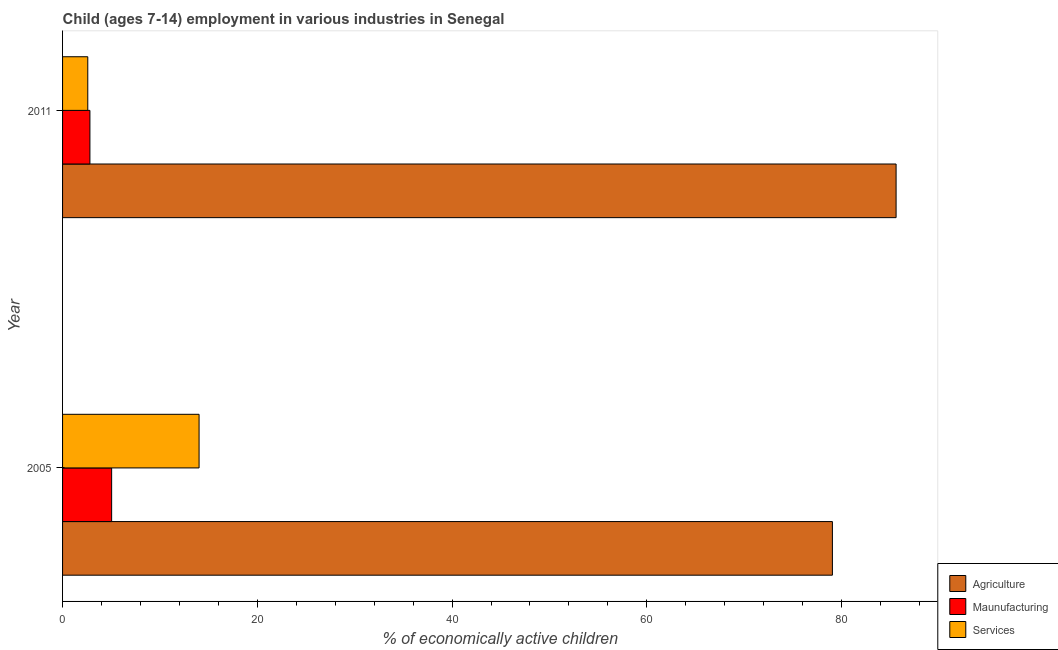Are the number of bars per tick equal to the number of legend labels?
Keep it short and to the point. Yes. How many bars are there on the 2nd tick from the top?
Offer a very short reply. 3. How many bars are there on the 2nd tick from the bottom?
Provide a succinct answer. 3. What is the label of the 2nd group of bars from the top?
Keep it short and to the point. 2005. What is the percentage of economically active children in services in 2011?
Provide a short and direct response. 2.59. Across all years, what is the maximum percentage of economically active children in services?
Provide a succinct answer. 14.02. Across all years, what is the minimum percentage of economically active children in manufacturing?
Make the answer very short. 2.81. In which year was the percentage of economically active children in agriculture maximum?
Your response must be concise. 2011. What is the total percentage of economically active children in agriculture in the graph?
Give a very brief answer. 164.66. What is the difference between the percentage of economically active children in agriculture in 2005 and that in 2011?
Your response must be concise. -6.54. What is the difference between the percentage of economically active children in services in 2005 and the percentage of economically active children in manufacturing in 2011?
Keep it short and to the point. 11.21. What is the average percentage of economically active children in agriculture per year?
Keep it short and to the point. 82.33. In the year 2011, what is the difference between the percentage of economically active children in manufacturing and percentage of economically active children in services?
Provide a succinct answer. 0.22. In how many years, is the percentage of economically active children in services greater than 28 %?
Provide a succinct answer. 0. What is the ratio of the percentage of economically active children in services in 2005 to that in 2011?
Keep it short and to the point. 5.41. Is the percentage of economically active children in agriculture in 2005 less than that in 2011?
Provide a succinct answer. Yes. Is the difference between the percentage of economically active children in agriculture in 2005 and 2011 greater than the difference between the percentage of economically active children in services in 2005 and 2011?
Your answer should be very brief. No. In how many years, is the percentage of economically active children in services greater than the average percentage of economically active children in services taken over all years?
Provide a short and direct response. 1. What does the 1st bar from the top in 2005 represents?
Your answer should be compact. Services. What does the 1st bar from the bottom in 2011 represents?
Your answer should be compact. Agriculture. Is it the case that in every year, the sum of the percentage of economically active children in agriculture and percentage of economically active children in manufacturing is greater than the percentage of economically active children in services?
Make the answer very short. Yes. How many years are there in the graph?
Provide a short and direct response. 2. Are the values on the major ticks of X-axis written in scientific E-notation?
Provide a short and direct response. No. Where does the legend appear in the graph?
Your answer should be very brief. Bottom right. How are the legend labels stacked?
Keep it short and to the point. Vertical. What is the title of the graph?
Offer a terse response. Child (ages 7-14) employment in various industries in Senegal. Does "Spain" appear as one of the legend labels in the graph?
Ensure brevity in your answer.  No. What is the label or title of the X-axis?
Provide a short and direct response. % of economically active children. What is the label or title of the Y-axis?
Offer a very short reply. Year. What is the % of economically active children in Agriculture in 2005?
Keep it short and to the point. 79.06. What is the % of economically active children of Maunufacturing in 2005?
Provide a short and direct response. 5.04. What is the % of economically active children of Services in 2005?
Give a very brief answer. 14.02. What is the % of economically active children in Agriculture in 2011?
Make the answer very short. 85.6. What is the % of economically active children in Maunufacturing in 2011?
Offer a terse response. 2.81. What is the % of economically active children of Services in 2011?
Ensure brevity in your answer.  2.59. Across all years, what is the maximum % of economically active children of Agriculture?
Offer a very short reply. 85.6. Across all years, what is the maximum % of economically active children in Maunufacturing?
Provide a succinct answer. 5.04. Across all years, what is the maximum % of economically active children of Services?
Your answer should be compact. 14.02. Across all years, what is the minimum % of economically active children in Agriculture?
Provide a succinct answer. 79.06. Across all years, what is the minimum % of economically active children in Maunufacturing?
Your answer should be very brief. 2.81. Across all years, what is the minimum % of economically active children of Services?
Your response must be concise. 2.59. What is the total % of economically active children in Agriculture in the graph?
Make the answer very short. 164.66. What is the total % of economically active children of Maunufacturing in the graph?
Offer a very short reply. 7.85. What is the total % of economically active children in Services in the graph?
Your answer should be very brief. 16.61. What is the difference between the % of economically active children in Agriculture in 2005 and that in 2011?
Your response must be concise. -6.54. What is the difference between the % of economically active children in Maunufacturing in 2005 and that in 2011?
Ensure brevity in your answer.  2.23. What is the difference between the % of economically active children in Services in 2005 and that in 2011?
Your answer should be very brief. 11.43. What is the difference between the % of economically active children of Agriculture in 2005 and the % of economically active children of Maunufacturing in 2011?
Provide a succinct answer. 76.25. What is the difference between the % of economically active children in Agriculture in 2005 and the % of economically active children in Services in 2011?
Your answer should be compact. 76.47. What is the difference between the % of economically active children of Maunufacturing in 2005 and the % of economically active children of Services in 2011?
Provide a short and direct response. 2.45. What is the average % of economically active children of Agriculture per year?
Keep it short and to the point. 82.33. What is the average % of economically active children of Maunufacturing per year?
Give a very brief answer. 3.92. What is the average % of economically active children of Services per year?
Give a very brief answer. 8.3. In the year 2005, what is the difference between the % of economically active children of Agriculture and % of economically active children of Maunufacturing?
Offer a very short reply. 74.02. In the year 2005, what is the difference between the % of economically active children in Agriculture and % of economically active children in Services?
Give a very brief answer. 65.04. In the year 2005, what is the difference between the % of economically active children in Maunufacturing and % of economically active children in Services?
Provide a short and direct response. -8.98. In the year 2011, what is the difference between the % of economically active children in Agriculture and % of economically active children in Maunufacturing?
Ensure brevity in your answer.  82.79. In the year 2011, what is the difference between the % of economically active children of Agriculture and % of economically active children of Services?
Keep it short and to the point. 83.01. In the year 2011, what is the difference between the % of economically active children of Maunufacturing and % of economically active children of Services?
Ensure brevity in your answer.  0.22. What is the ratio of the % of economically active children of Agriculture in 2005 to that in 2011?
Make the answer very short. 0.92. What is the ratio of the % of economically active children in Maunufacturing in 2005 to that in 2011?
Your answer should be compact. 1.79. What is the ratio of the % of economically active children in Services in 2005 to that in 2011?
Your answer should be compact. 5.41. What is the difference between the highest and the second highest % of economically active children of Agriculture?
Offer a very short reply. 6.54. What is the difference between the highest and the second highest % of economically active children of Maunufacturing?
Offer a very short reply. 2.23. What is the difference between the highest and the second highest % of economically active children of Services?
Offer a very short reply. 11.43. What is the difference between the highest and the lowest % of economically active children of Agriculture?
Ensure brevity in your answer.  6.54. What is the difference between the highest and the lowest % of economically active children of Maunufacturing?
Provide a short and direct response. 2.23. What is the difference between the highest and the lowest % of economically active children of Services?
Your answer should be compact. 11.43. 